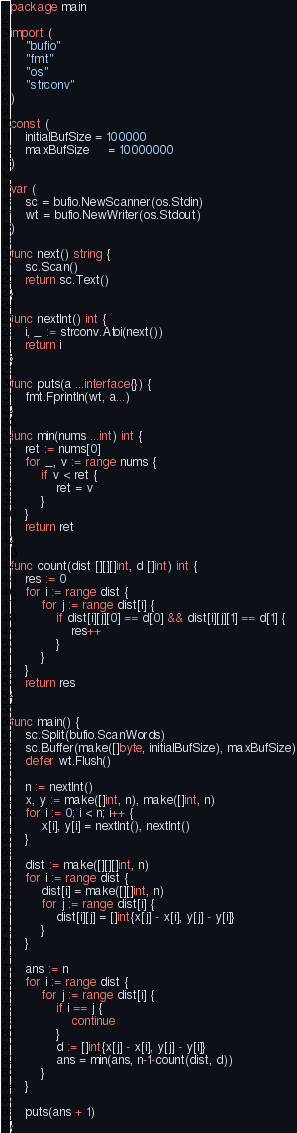<code> <loc_0><loc_0><loc_500><loc_500><_Go_>package main

import (
	"bufio"
	"fmt"
	"os"
	"strconv"
)

const (
	initialBufSize = 100000
	maxBufSize     = 10000000
)

var (
	sc = bufio.NewScanner(os.Stdin)
	wt = bufio.NewWriter(os.Stdout)
)

func next() string {
	sc.Scan()
	return sc.Text()
}

func nextInt() int {
	i, _ := strconv.Atoi(next())
	return i
}

func puts(a ...interface{}) {
	fmt.Fprintln(wt, a...)
}

func min(nums ...int) int {
	ret := nums[0]
	for _, v := range nums {
		if v < ret {
			ret = v
		}
	}
	return ret
}

func count(dist [][][]int, d []int) int {
	res := 0
	for i := range dist {
		for j := range dist[i] {
			if dist[i][j][0] == d[0] && dist[i][j][1] == d[1] {
				res++
			}
		}
	}
	return res
}

func main() {
	sc.Split(bufio.ScanWords)
	sc.Buffer(make([]byte, initialBufSize), maxBufSize)
	defer wt.Flush()

	n := nextInt()
	x, y := make([]int, n), make([]int, n)
	for i := 0; i < n; i++ {
		x[i], y[i] = nextInt(), nextInt()
	}

	dist := make([][][]int, n)
	for i := range dist {
		dist[i] = make([][]int, n)
		for j := range dist[i] {
			dist[i][j] = []int{x[j] - x[i], y[j] - y[i]}
		}
	}

	ans := n
	for i := range dist {
		for j := range dist[i] {
			if i == j {
				continue
			}
			d := []int{x[j] - x[i], y[j] - y[i]}
			ans = min(ans, n-1-count(dist, d))
		}
	}

	puts(ans + 1)
}
</code> 